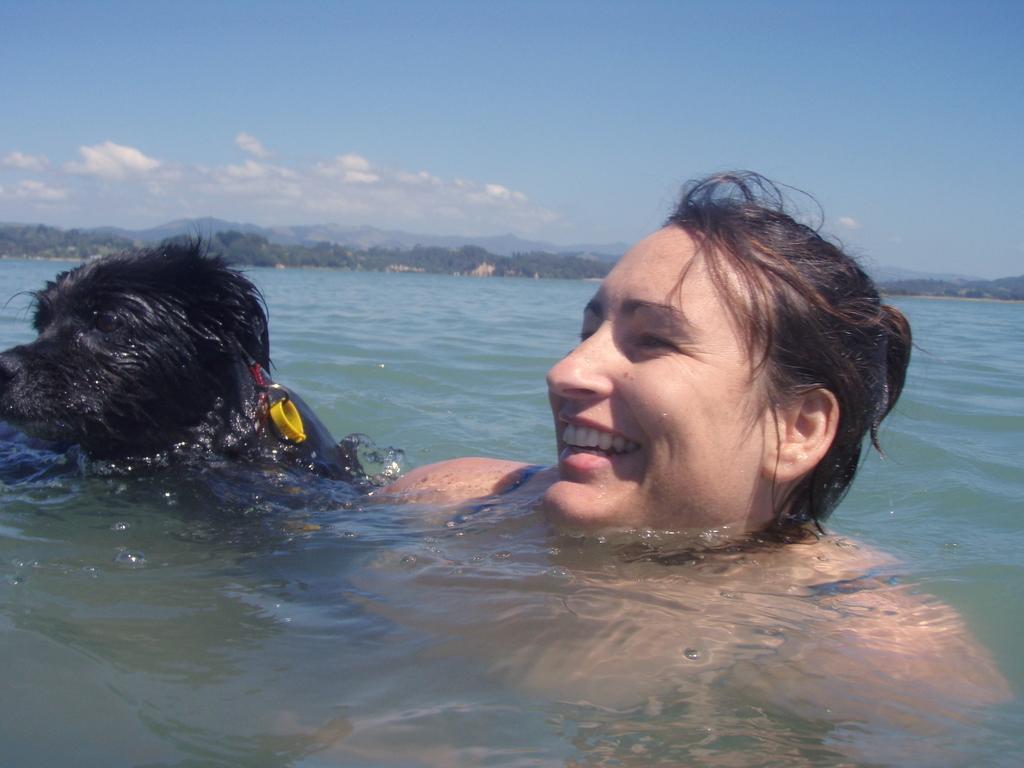Please provide a concise description of this image. In this picture we can see a few people in the water. There are a few trees and mountains visible in the background. Sky is blue in color and cloudy. 